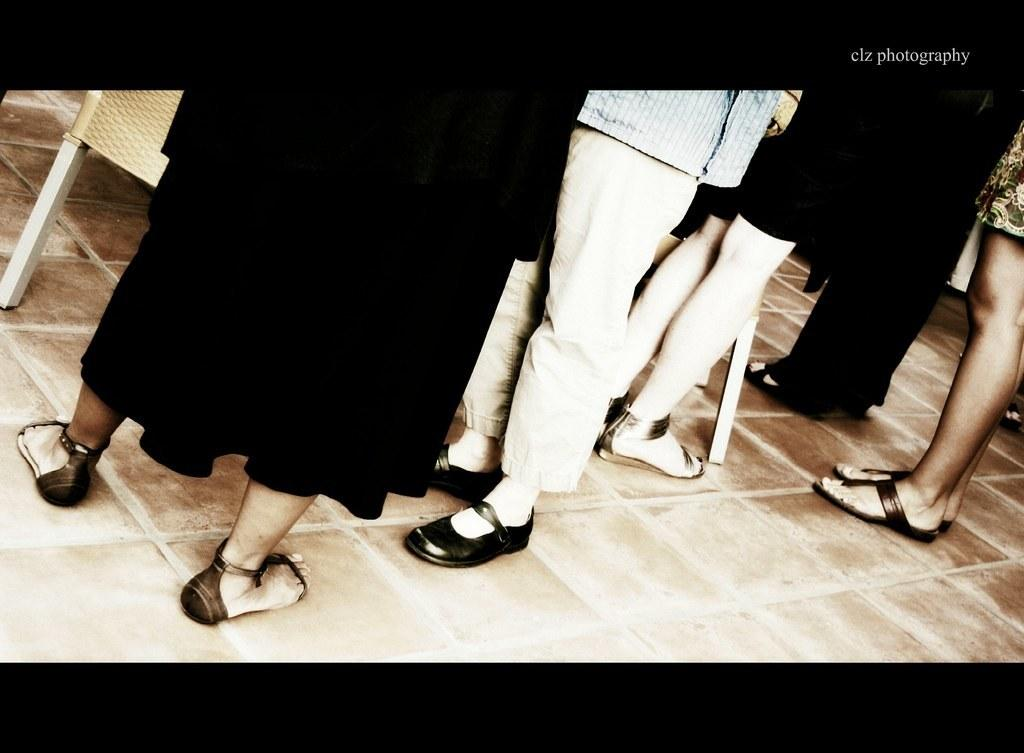What can be seen in the image in terms of human presence? There are people standing in the image. What objects are present that might be used for sitting? There are chairs in the image. What surface is visible at the bottom of the image? There is a floor visible at the bottom of the image. What type of information is displayed at the top of the image? There is some text visible at the top of the image. Can you tell me how many pieces of quartz are on the floor in the image? There is no quartz present in the image; only people, chairs, and text are visible. What type of slope can be seen in the image? There is no slope present in the image; it features a flat floor. 